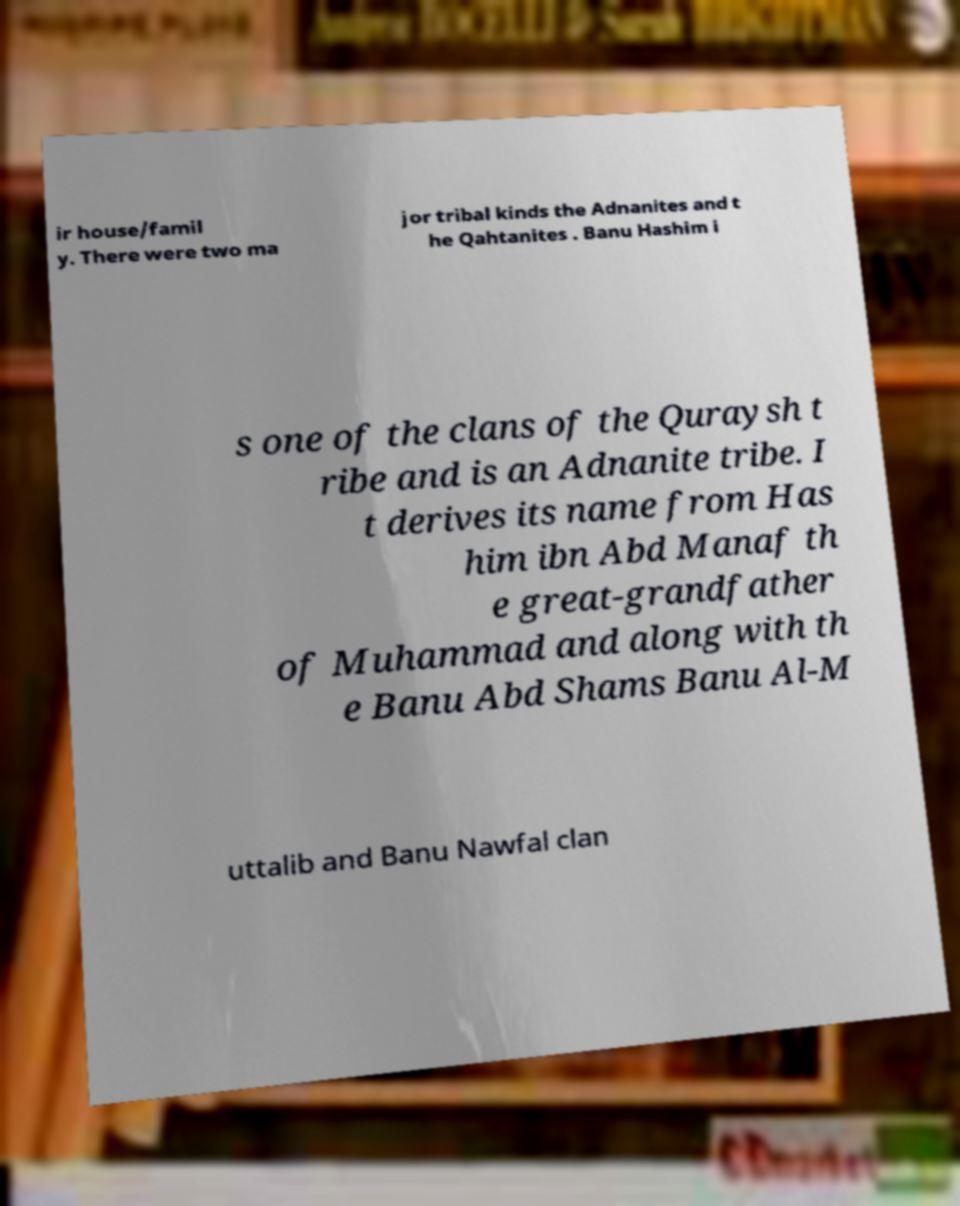There's text embedded in this image that I need extracted. Can you transcribe it verbatim? ir house/famil y. There were two ma jor tribal kinds the Adnanites and t he Qahtanites . Banu Hashim i s one of the clans of the Quraysh t ribe and is an Adnanite tribe. I t derives its name from Has him ibn Abd Manaf th e great-grandfather of Muhammad and along with th e Banu Abd Shams Banu Al-M uttalib and Banu Nawfal clan 